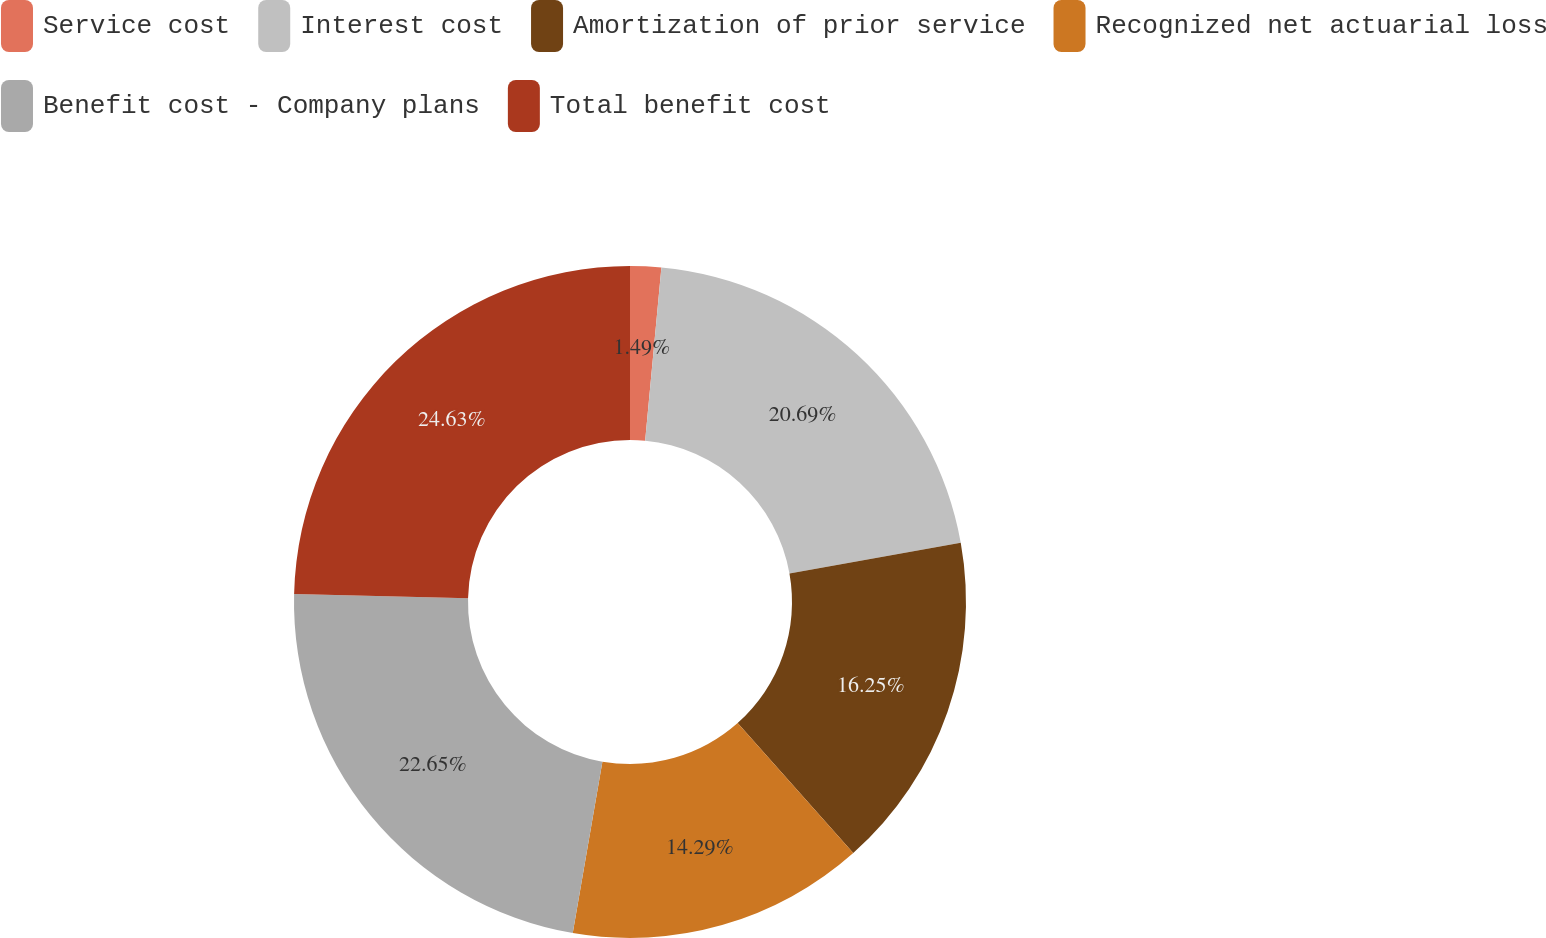Convert chart to OTSL. <chart><loc_0><loc_0><loc_500><loc_500><pie_chart><fcel>Service cost<fcel>Interest cost<fcel>Amortization of prior service<fcel>Recognized net actuarial loss<fcel>Benefit cost - Company plans<fcel>Total benefit cost<nl><fcel>1.49%<fcel>20.69%<fcel>16.25%<fcel>14.29%<fcel>22.65%<fcel>24.62%<nl></chart> 